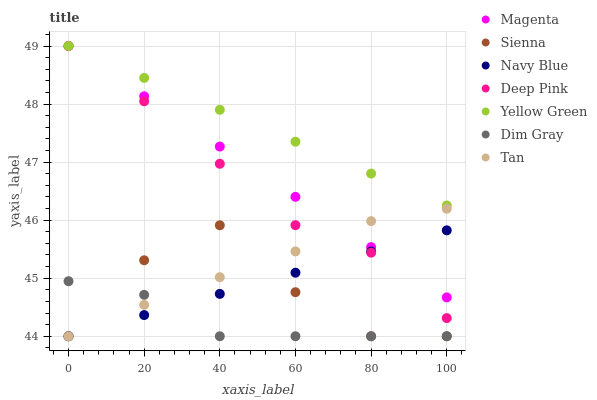Does Dim Gray have the minimum area under the curve?
Answer yes or no. Yes. Does Yellow Green have the maximum area under the curve?
Answer yes or no. Yes. Does Navy Blue have the minimum area under the curve?
Answer yes or no. No. Does Navy Blue have the maximum area under the curve?
Answer yes or no. No. Is Navy Blue the smoothest?
Answer yes or no. Yes. Is Sienna the roughest?
Answer yes or no. Yes. Is Yellow Green the smoothest?
Answer yes or no. No. Is Yellow Green the roughest?
Answer yes or no. No. Does Navy Blue have the lowest value?
Answer yes or no. Yes. Does Yellow Green have the lowest value?
Answer yes or no. No. Does Magenta have the highest value?
Answer yes or no. Yes. Does Navy Blue have the highest value?
Answer yes or no. No. Is Navy Blue less than Yellow Green?
Answer yes or no. Yes. Is Yellow Green greater than Navy Blue?
Answer yes or no. Yes. Does Magenta intersect Yellow Green?
Answer yes or no. Yes. Is Magenta less than Yellow Green?
Answer yes or no. No. Is Magenta greater than Yellow Green?
Answer yes or no. No. Does Navy Blue intersect Yellow Green?
Answer yes or no. No. 